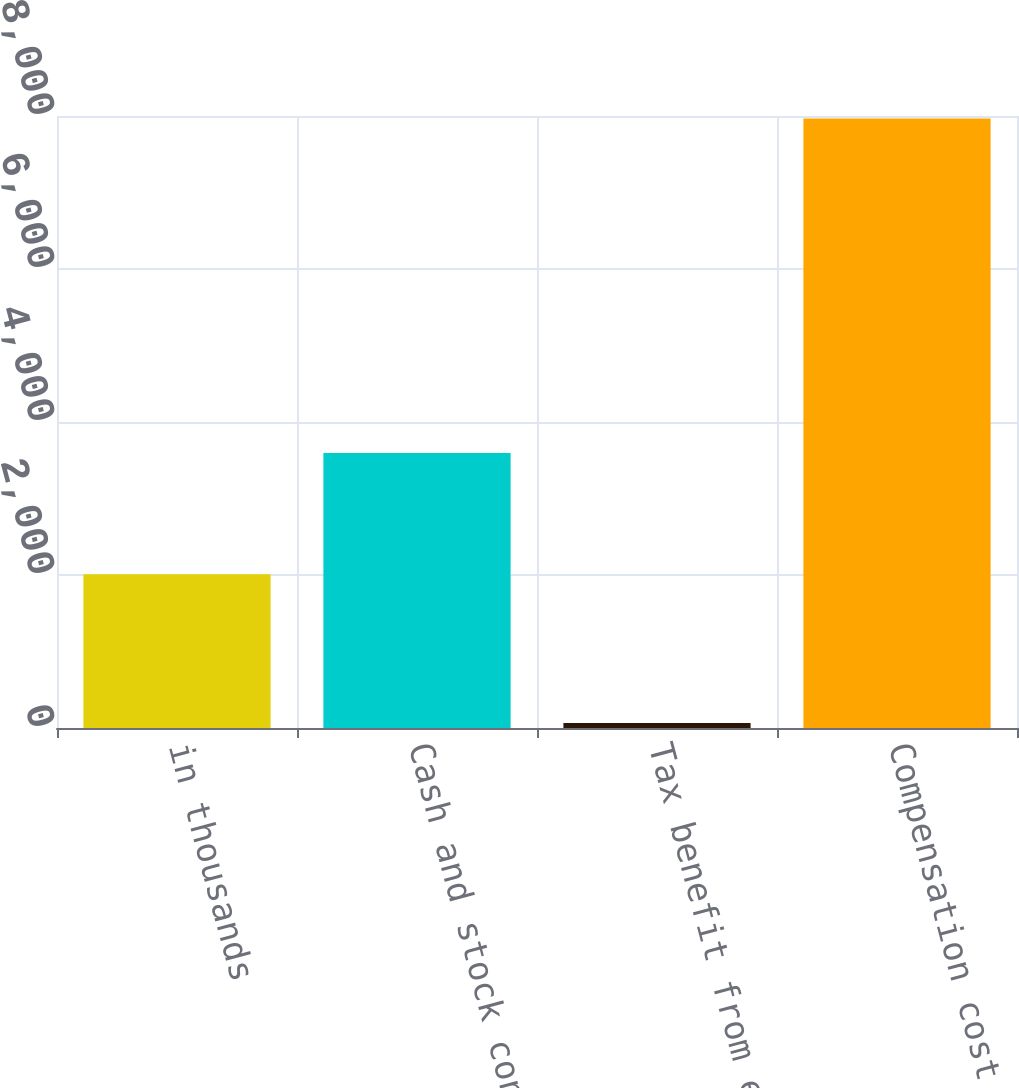Convert chart. <chart><loc_0><loc_0><loc_500><loc_500><bar_chart><fcel>in thousands<fcel>Cash and stock consideration<fcel>Tax benefit from exercises<fcel>Compensation cost<nl><fcel>2011<fcel>3596<fcel>66<fcel>7968<nl></chart> 